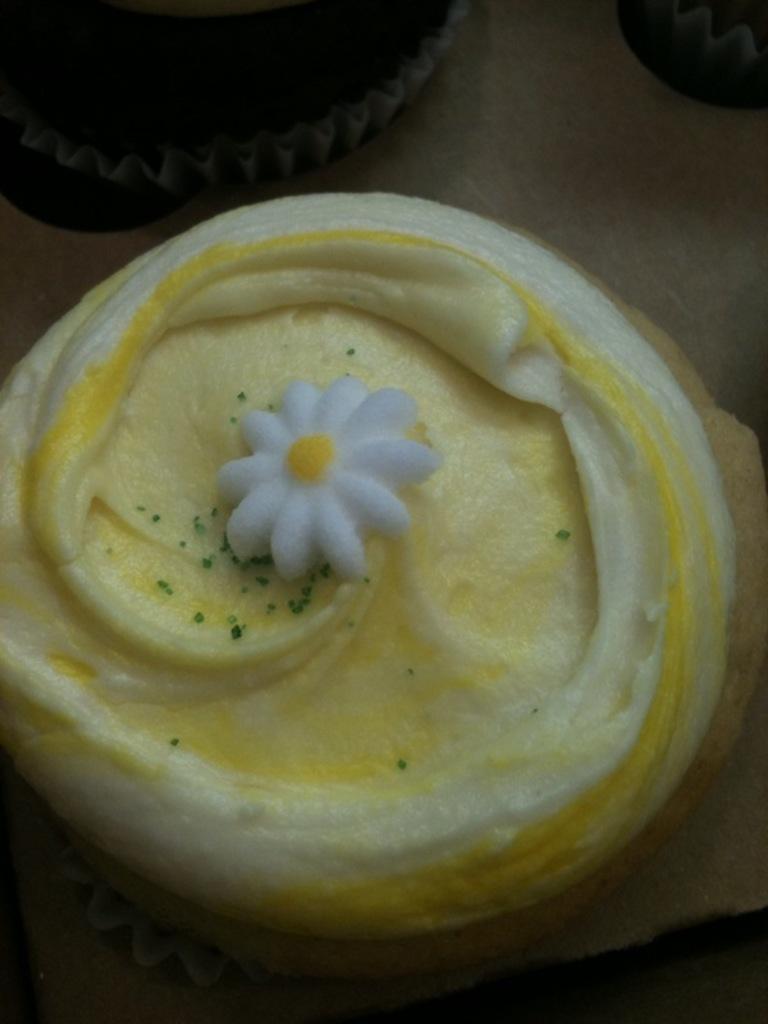Please provide a concise description of this image. In this picture we can see cupcakes with a cream on it and these are placed on a platform. 